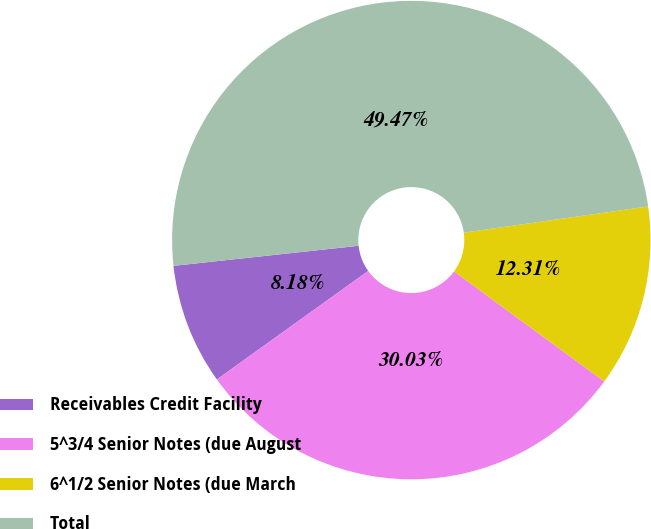Convert chart to OTSL. <chart><loc_0><loc_0><loc_500><loc_500><pie_chart><fcel>Receivables Credit Facility<fcel>5^3/4 Senior Notes (due August<fcel>6^1/2 Senior Notes (due March<fcel>Total<nl><fcel>8.18%<fcel>30.03%<fcel>12.31%<fcel>49.47%<nl></chart> 